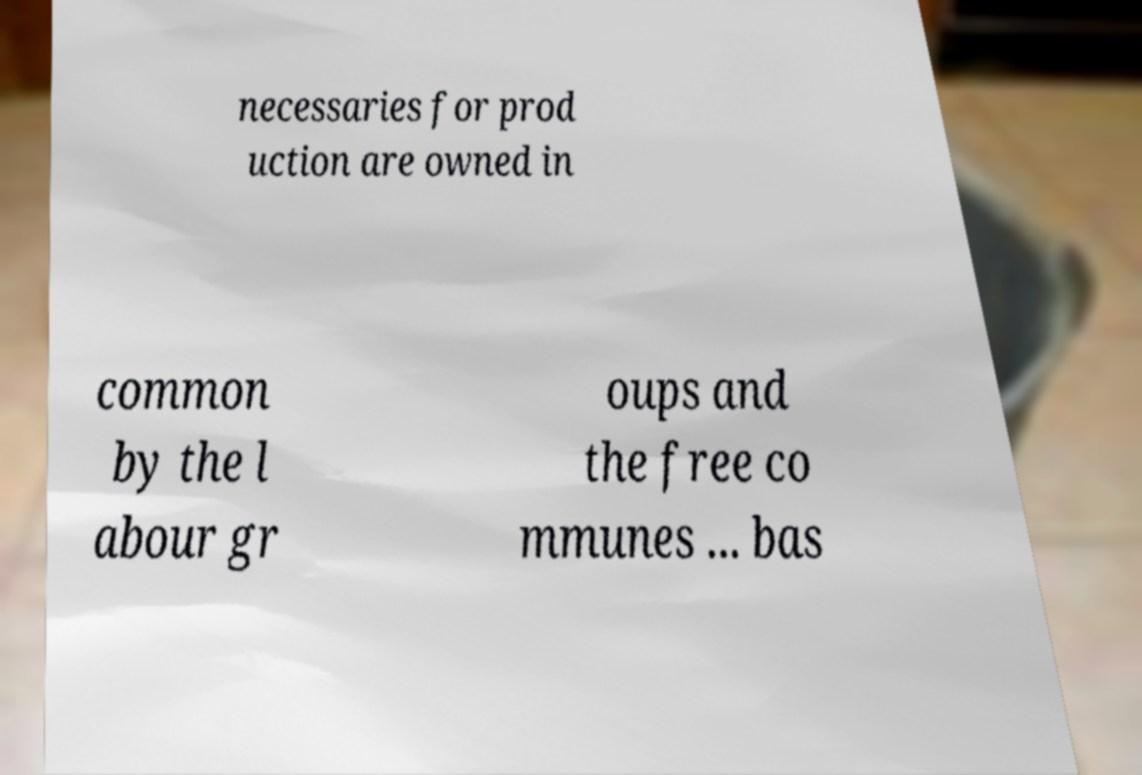Please identify and transcribe the text found in this image. necessaries for prod uction are owned in common by the l abour gr oups and the free co mmunes ... bas 